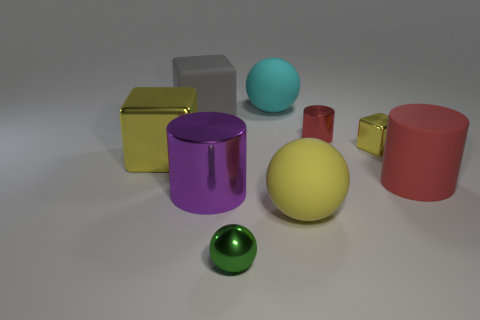Add 1 big cyan matte objects. How many objects exist? 10 Subtract all metal spheres. How many spheres are left? 2 Subtract all large red balls. Subtract all small red shiny cylinders. How many objects are left? 8 Add 3 big cyan rubber things. How many big cyan rubber things are left? 4 Add 1 metal cylinders. How many metal cylinders exist? 3 Subtract all red cylinders. How many cylinders are left? 1 Subtract 1 yellow spheres. How many objects are left? 8 Subtract all cubes. How many objects are left? 6 Subtract 3 spheres. How many spheres are left? 0 Subtract all purple balls. Subtract all blue cylinders. How many balls are left? 3 